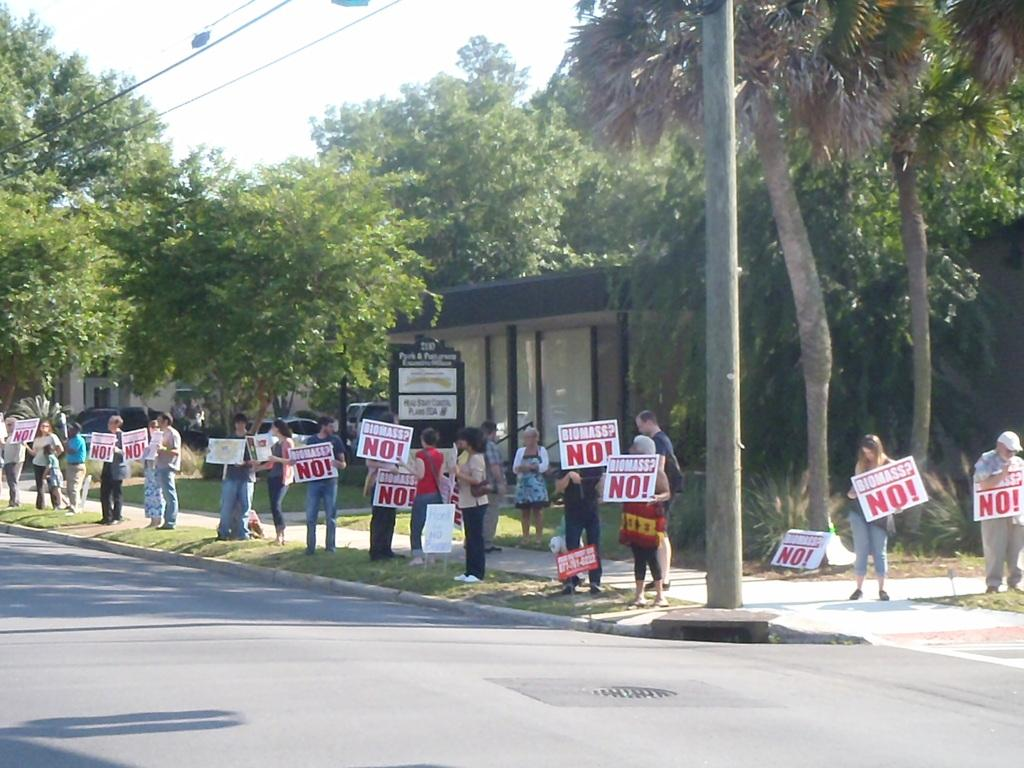<image>
Summarize the visual content of the image. A group of protesters stand along a street with No! signs. 